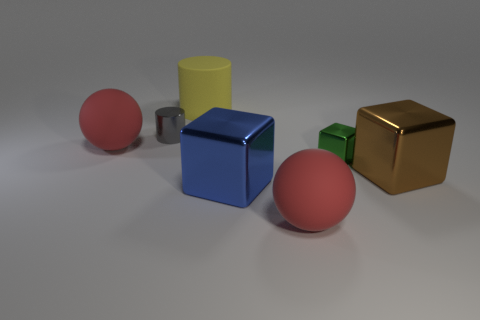How many small objects have the same shape as the large yellow matte object?
Make the answer very short. 1. Are the big ball that is to the left of the yellow cylinder and the brown block made of the same material?
Your answer should be very brief. No. How many balls are either brown matte things or big rubber things?
Keep it short and to the point. 2. The big matte object behind the metallic thing that is behind the sphere that is on the left side of the yellow cylinder is what shape?
Your answer should be very brief. Cylinder. How many brown objects are the same size as the matte cylinder?
Offer a very short reply. 1. Are there any blue shiny objects in front of the large ball to the right of the gray thing?
Your answer should be compact. No. What number of objects are either red spheres or yellow rubber cylinders?
Your answer should be very brief. 3. There is a metallic block to the right of the tiny object on the right side of the big matte sphere that is right of the matte cylinder; what is its color?
Ensure brevity in your answer.  Brown. Are there any other things that have the same color as the tiny metallic block?
Your response must be concise. No. Do the green cube and the gray shiny cylinder have the same size?
Offer a terse response. Yes. 